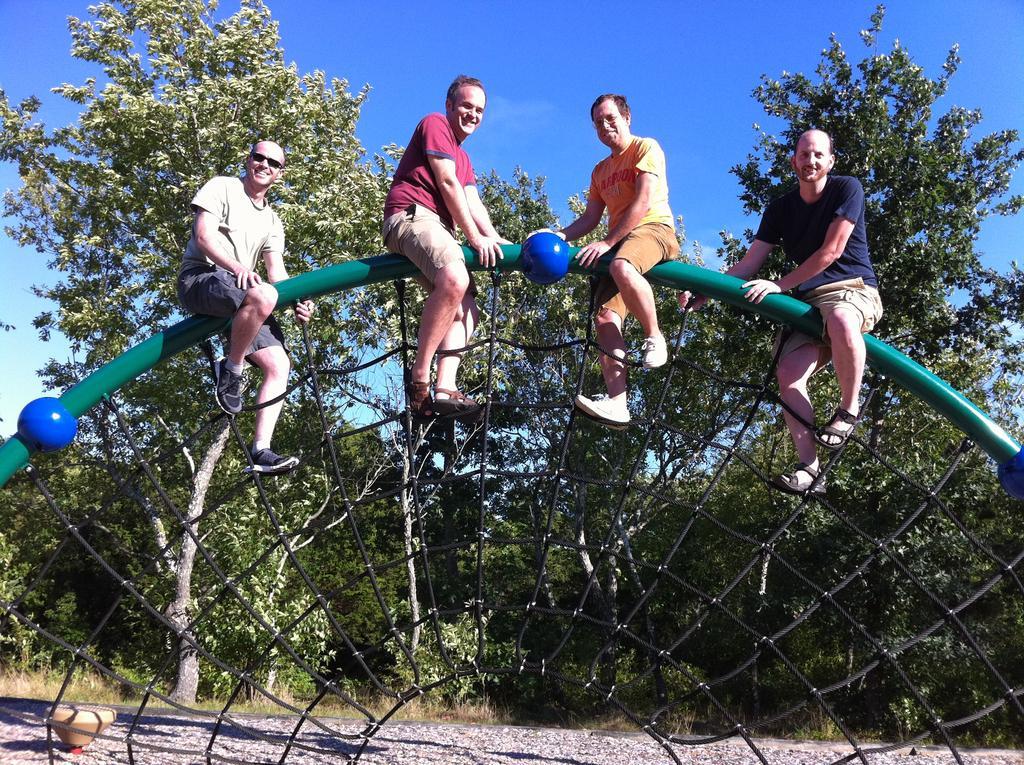Please provide a concise description of this image. In this image there are four people sitting on the rod. Behind them there are trees. In the background of the image there is sky. At the bottom of the image there is a road. 